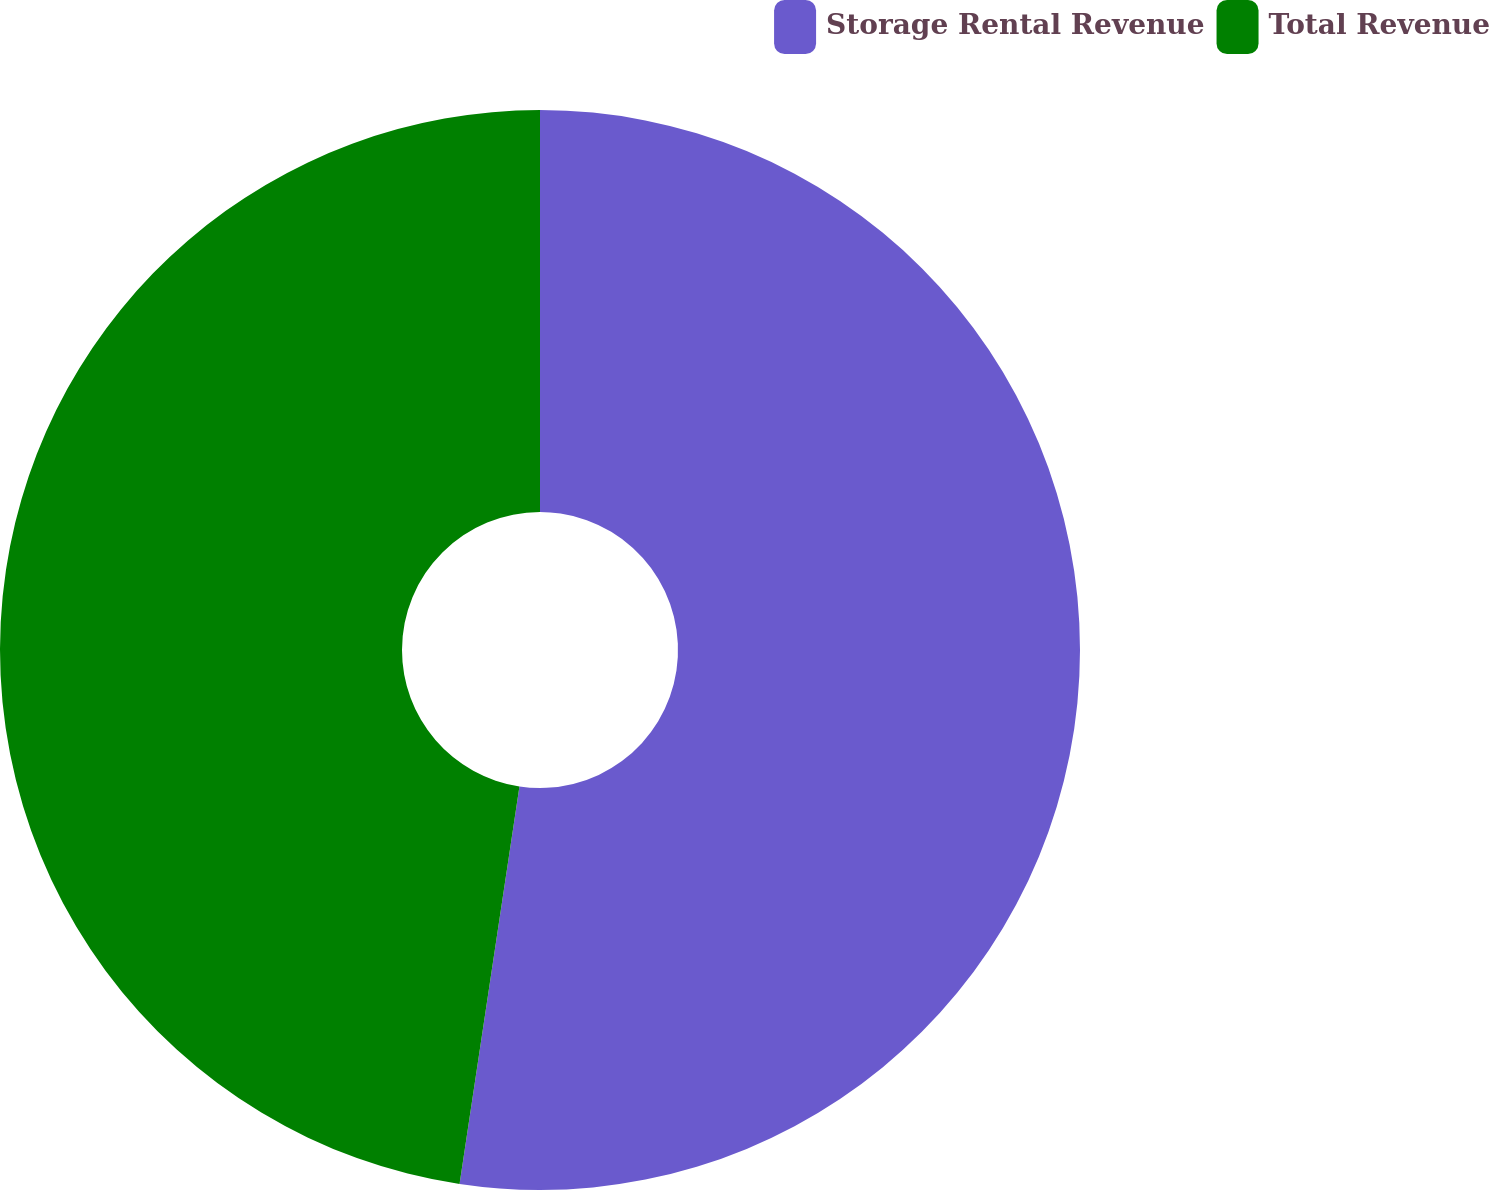Convert chart to OTSL. <chart><loc_0><loc_0><loc_500><loc_500><pie_chart><fcel>Storage Rental Revenue<fcel>Total Revenue<nl><fcel>52.38%<fcel>47.62%<nl></chart> 